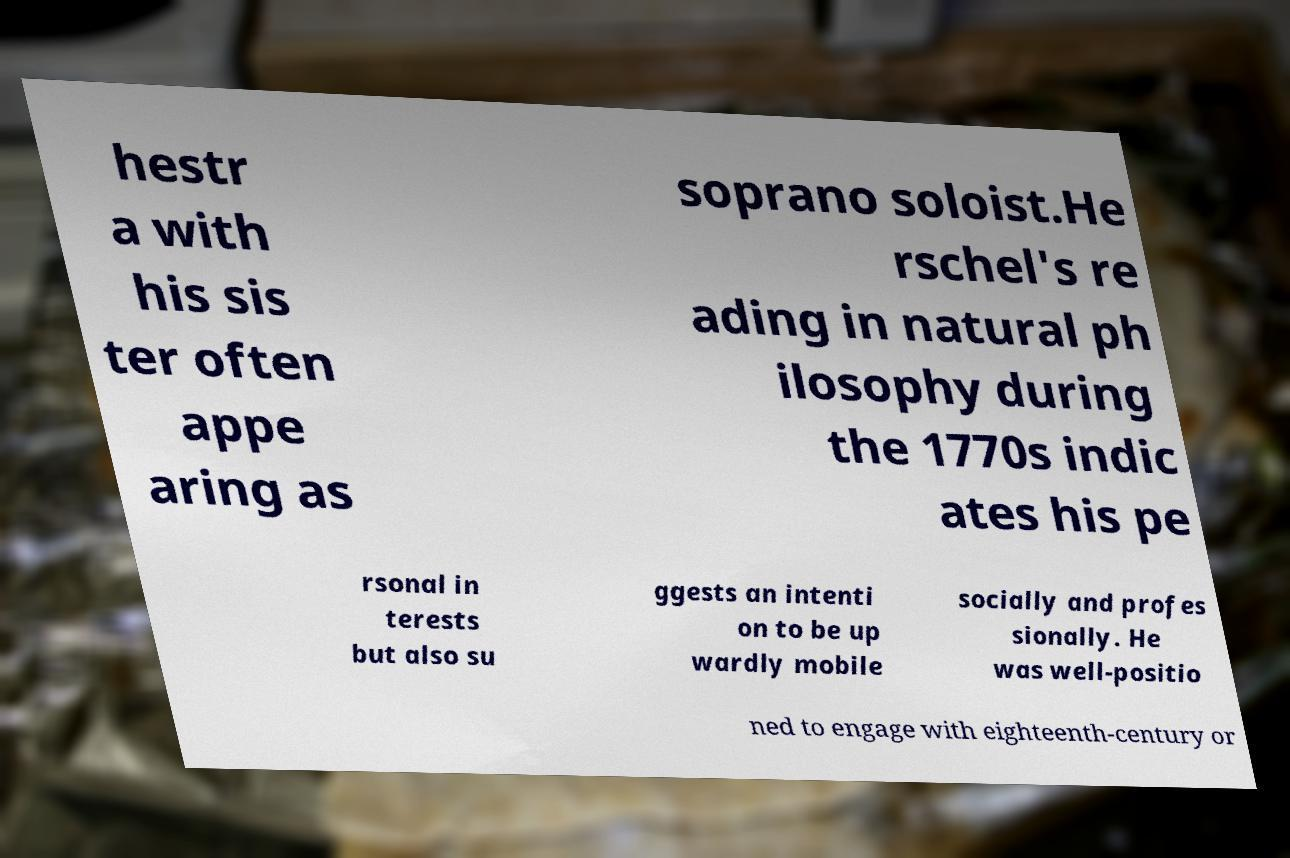For documentation purposes, I need the text within this image transcribed. Could you provide that? hestr a with his sis ter often appe aring as soprano soloist.He rschel's re ading in natural ph ilosophy during the 1770s indic ates his pe rsonal in terests but also su ggests an intenti on to be up wardly mobile socially and profes sionally. He was well-positio ned to engage with eighteenth-century or 